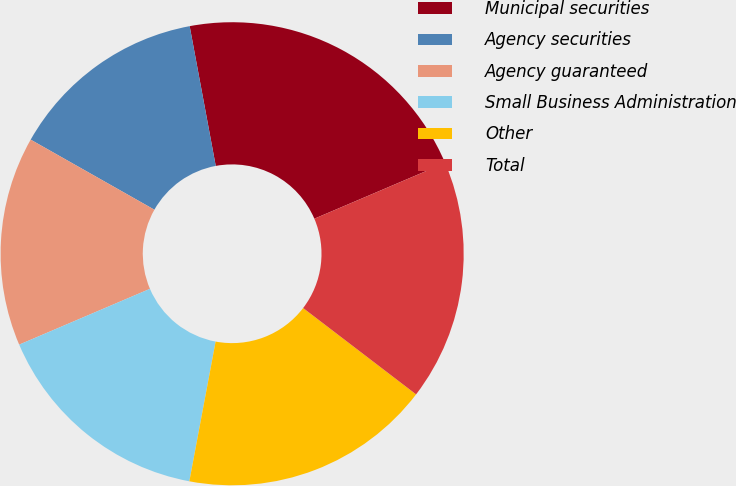Convert chart. <chart><loc_0><loc_0><loc_500><loc_500><pie_chart><fcel>Municipal securities<fcel>Agency securities<fcel>Agency guaranteed<fcel>Small Business Administration<fcel>Other<fcel>Total<nl><fcel>21.52%<fcel>13.86%<fcel>14.62%<fcel>15.62%<fcel>17.57%<fcel>16.8%<nl></chart> 